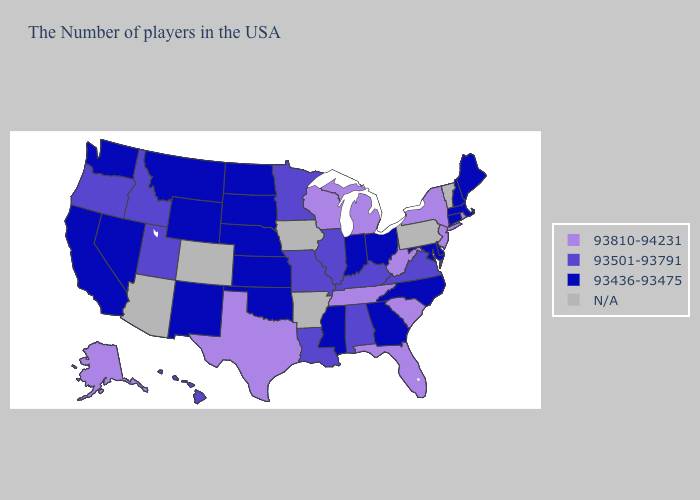What is the value of Maryland?
Short answer required. 93436-93475. Among the states that border Kansas , does Missouri have the lowest value?
Concise answer only. No. What is the value of Colorado?
Quick response, please. N/A. What is the highest value in the USA?
Answer briefly. 93810-94231. Among the states that border Maryland , which have the lowest value?
Give a very brief answer. Delaware. Name the states that have a value in the range N/A?
Concise answer only. Vermont, Pennsylvania, Arkansas, Iowa, Colorado, Arizona. Does the map have missing data?
Be succinct. Yes. Name the states that have a value in the range 93436-93475?
Answer briefly. Maine, Massachusetts, New Hampshire, Connecticut, Delaware, Maryland, North Carolina, Ohio, Georgia, Indiana, Mississippi, Kansas, Nebraska, Oklahoma, South Dakota, North Dakota, Wyoming, New Mexico, Montana, Nevada, California, Washington. What is the value of Alaska?
Short answer required. 93810-94231. What is the lowest value in states that border Wisconsin?
Write a very short answer. 93501-93791. Does South Dakota have the highest value in the USA?
Short answer required. No. What is the value of Pennsylvania?
Give a very brief answer. N/A. What is the value of Nebraska?
Give a very brief answer. 93436-93475. What is the value of Washington?
Short answer required. 93436-93475. 